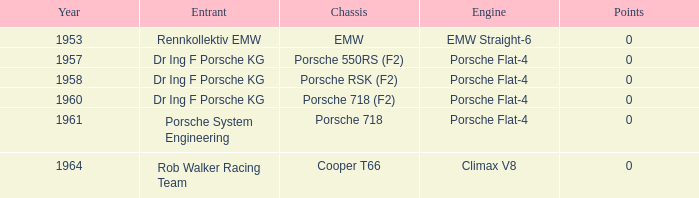Which year experienced above 0 points? 0.0. 